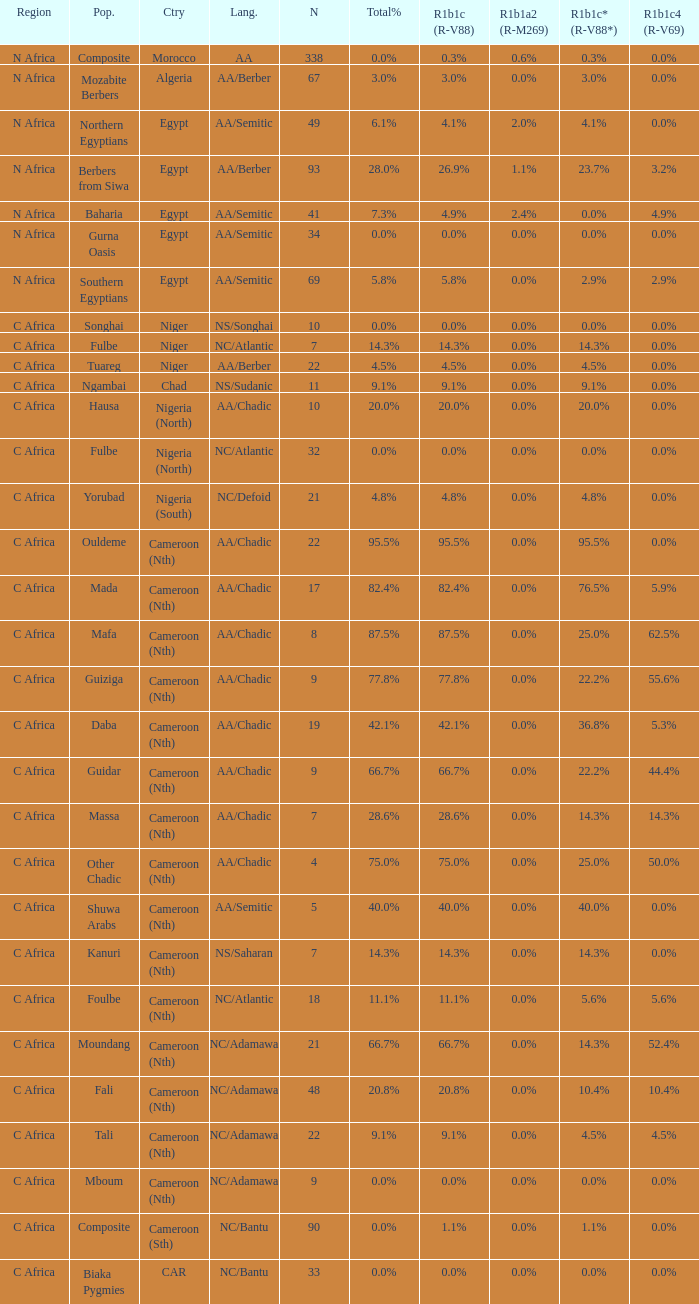How many n are listed for 0.6% r1b1a2 (r-m269)? 1.0. 